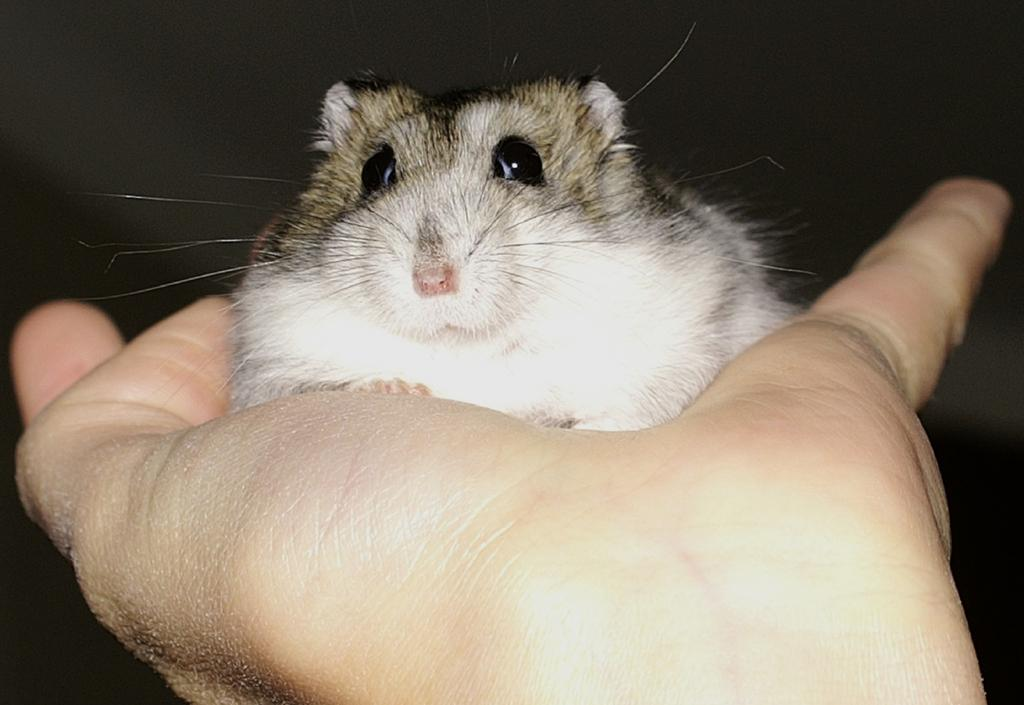What is present in the image? There is a person in the image. What is the person holding in their hand? The person is holding a mouse in their hand. What type of credit card is the person using in the image? There is no credit card present in the image; the person is holding a mouse. What direction is the person facing in the image? The provided facts do not mention the direction the person is facing, so it cannot be determined from the image. 